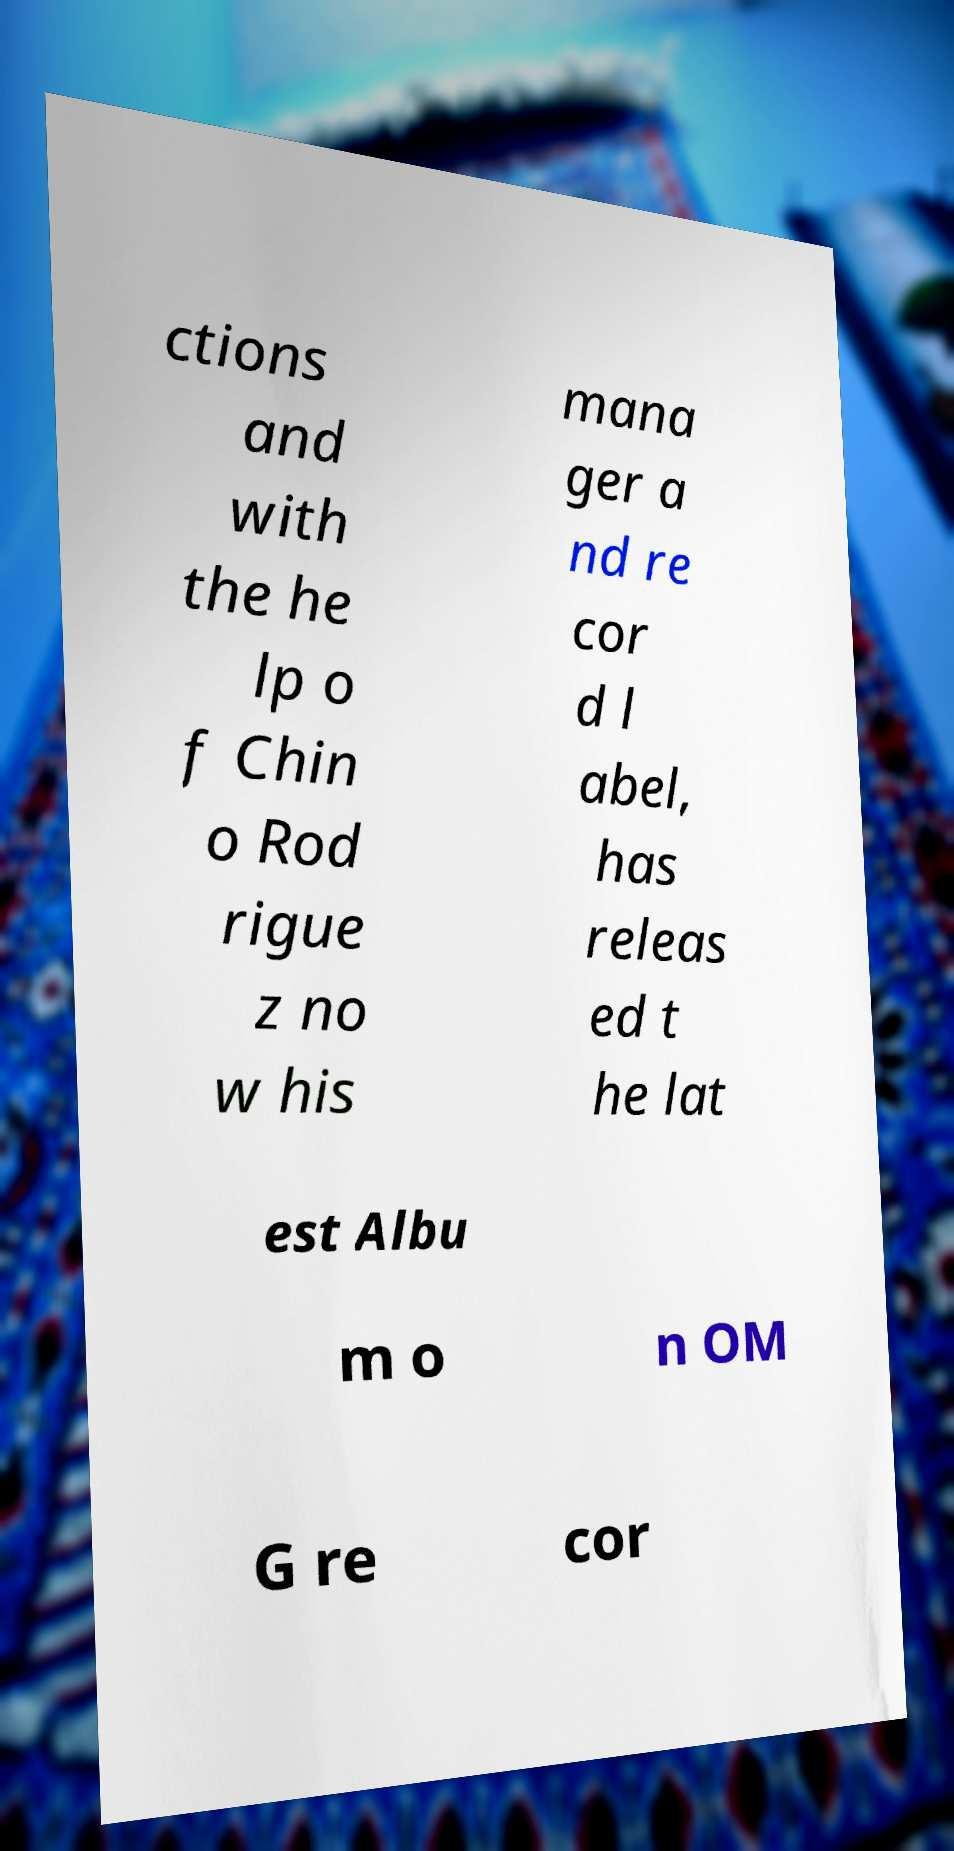What messages or text are displayed in this image? I need them in a readable, typed format. ctions and with the he lp o f Chin o Rod rigue z no w his mana ger a nd re cor d l abel, has releas ed t he lat est Albu m o n OM G re cor 